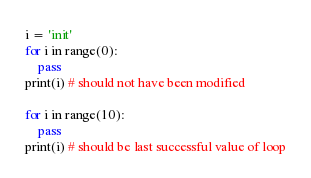<code> <loc_0><loc_0><loc_500><loc_500><_Python_>i = 'init'
for i in range(0):
    pass
print(i) # should not have been modified

for i in range(10):
    pass
print(i) # should be last successful value of loop
</code> 